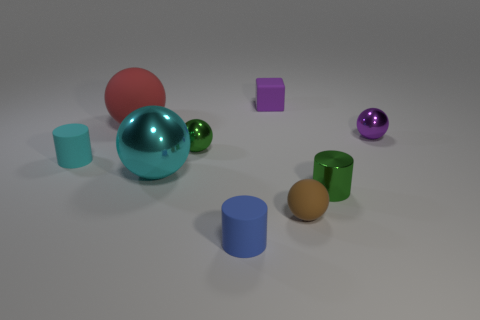Subtract all brown spheres. How many spheres are left? 4 Subtract all cyan balls. How many balls are left? 4 Subtract all blue balls. Subtract all gray cubes. How many balls are left? 5 Subtract all cubes. How many objects are left? 8 Subtract 1 blue cylinders. How many objects are left? 8 Subtract all big brown cubes. Subtract all small blocks. How many objects are left? 8 Add 3 small green metallic things. How many small green metallic things are left? 5 Add 4 large cyan things. How many large cyan things exist? 5 